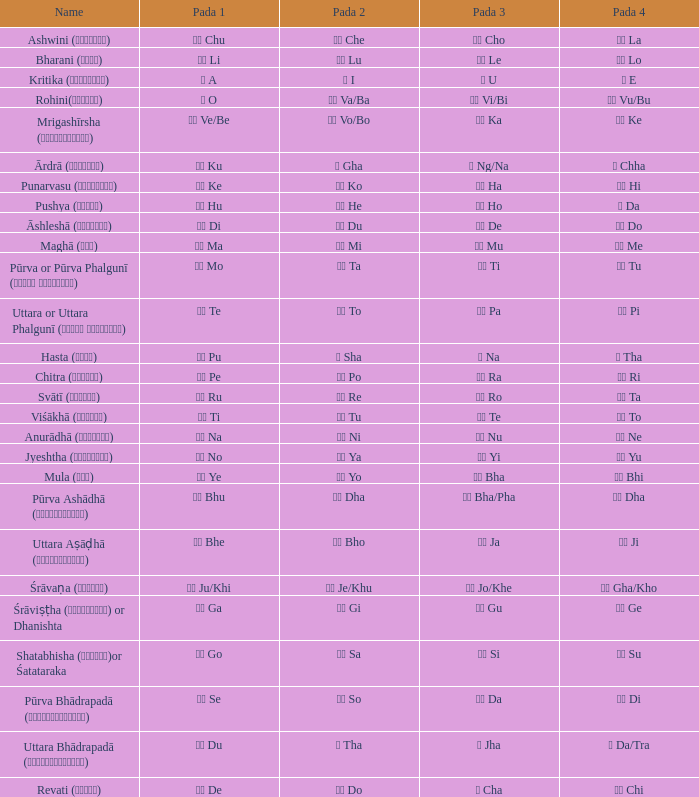Which pada 4 has a pada 2 of थ tha? ञ Da/Tra. 